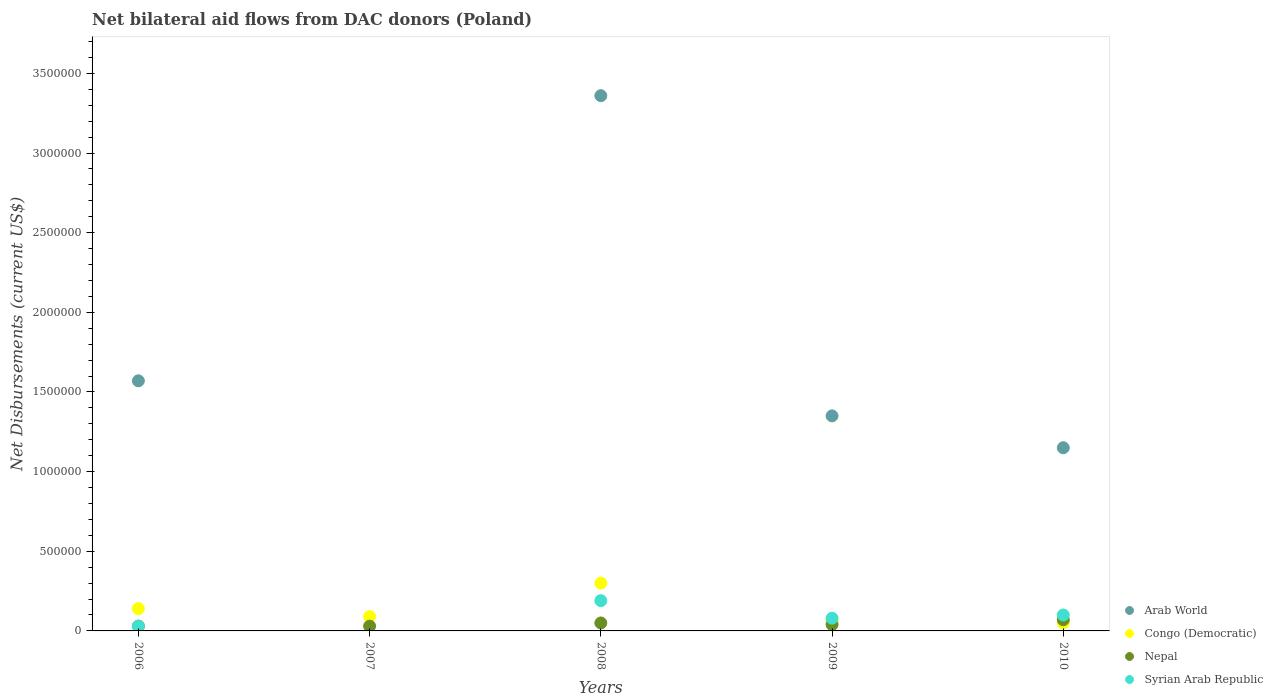Is the number of dotlines equal to the number of legend labels?
Ensure brevity in your answer.  No. What is the net bilateral aid flows in Nepal in 2007?
Make the answer very short. 3.00e+04. Across all years, what is the maximum net bilateral aid flows in Arab World?
Your answer should be very brief. 3.36e+06. What is the total net bilateral aid flows in Arab World in the graph?
Your response must be concise. 7.43e+06. What is the difference between the net bilateral aid flows in Nepal in 2006 and that in 2010?
Your answer should be compact. -4.00e+04. What is the difference between the net bilateral aid flows in Nepal in 2007 and the net bilateral aid flows in Arab World in 2010?
Ensure brevity in your answer.  -1.12e+06. What is the average net bilateral aid flows in Nepal per year?
Provide a succinct answer. 4.40e+04. In the year 2008, what is the difference between the net bilateral aid flows in Nepal and net bilateral aid flows in Arab World?
Your response must be concise. -3.31e+06. What is the ratio of the net bilateral aid flows in Congo (Democratic) in 2007 to that in 2009?
Keep it short and to the point. 1.5. What is the difference between the highest and the second highest net bilateral aid flows in Arab World?
Provide a short and direct response. 1.79e+06. What is the difference between the highest and the lowest net bilateral aid flows in Congo (Democratic)?
Your answer should be very brief. 2.50e+05. In how many years, is the net bilateral aid flows in Syrian Arab Republic greater than the average net bilateral aid flows in Syrian Arab Republic taken over all years?
Give a very brief answer. 2. Is the sum of the net bilateral aid flows in Syrian Arab Republic in 2008 and 2010 greater than the maximum net bilateral aid flows in Nepal across all years?
Ensure brevity in your answer.  Yes. Is it the case that in every year, the sum of the net bilateral aid flows in Arab World and net bilateral aid flows in Syrian Arab Republic  is greater than the sum of net bilateral aid flows in Nepal and net bilateral aid flows in Congo (Democratic)?
Ensure brevity in your answer.  No. Is it the case that in every year, the sum of the net bilateral aid flows in Syrian Arab Republic and net bilateral aid flows in Nepal  is greater than the net bilateral aid flows in Arab World?
Your answer should be very brief. No. Is the net bilateral aid flows in Syrian Arab Republic strictly greater than the net bilateral aid flows in Nepal over the years?
Give a very brief answer. No. Is the net bilateral aid flows in Nepal strictly less than the net bilateral aid flows in Arab World over the years?
Make the answer very short. No. How many dotlines are there?
Your response must be concise. 4. Are the values on the major ticks of Y-axis written in scientific E-notation?
Provide a succinct answer. No. Where does the legend appear in the graph?
Provide a short and direct response. Bottom right. How are the legend labels stacked?
Your answer should be compact. Vertical. What is the title of the graph?
Offer a very short reply. Net bilateral aid flows from DAC donors (Poland). What is the label or title of the Y-axis?
Keep it short and to the point. Net Disbursements (current US$). What is the Net Disbursements (current US$) in Arab World in 2006?
Your response must be concise. 1.57e+06. What is the Net Disbursements (current US$) in Congo (Democratic) in 2006?
Your answer should be very brief. 1.40e+05. What is the Net Disbursements (current US$) in Nepal in 2006?
Keep it short and to the point. 3.00e+04. What is the Net Disbursements (current US$) of Congo (Democratic) in 2007?
Make the answer very short. 9.00e+04. What is the Net Disbursements (current US$) in Nepal in 2007?
Your response must be concise. 3.00e+04. What is the Net Disbursements (current US$) of Syrian Arab Republic in 2007?
Provide a short and direct response. 0. What is the Net Disbursements (current US$) of Arab World in 2008?
Give a very brief answer. 3.36e+06. What is the Net Disbursements (current US$) of Syrian Arab Republic in 2008?
Your response must be concise. 1.90e+05. What is the Net Disbursements (current US$) of Arab World in 2009?
Ensure brevity in your answer.  1.35e+06. What is the Net Disbursements (current US$) in Congo (Democratic) in 2009?
Offer a very short reply. 6.00e+04. What is the Net Disbursements (current US$) in Syrian Arab Republic in 2009?
Provide a succinct answer. 8.00e+04. What is the Net Disbursements (current US$) of Arab World in 2010?
Ensure brevity in your answer.  1.15e+06. What is the Net Disbursements (current US$) in Congo (Democratic) in 2010?
Keep it short and to the point. 5.00e+04. What is the Net Disbursements (current US$) of Syrian Arab Republic in 2010?
Keep it short and to the point. 1.00e+05. Across all years, what is the maximum Net Disbursements (current US$) in Arab World?
Your answer should be very brief. 3.36e+06. Across all years, what is the maximum Net Disbursements (current US$) in Congo (Democratic)?
Provide a succinct answer. 3.00e+05. Across all years, what is the maximum Net Disbursements (current US$) in Syrian Arab Republic?
Your response must be concise. 1.90e+05. Across all years, what is the minimum Net Disbursements (current US$) in Nepal?
Keep it short and to the point. 3.00e+04. What is the total Net Disbursements (current US$) in Arab World in the graph?
Provide a short and direct response. 7.43e+06. What is the total Net Disbursements (current US$) in Congo (Democratic) in the graph?
Provide a short and direct response. 6.40e+05. What is the total Net Disbursements (current US$) in Nepal in the graph?
Your answer should be very brief. 2.20e+05. What is the total Net Disbursements (current US$) of Syrian Arab Republic in the graph?
Keep it short and to the point. 4.00e+05. What is the difference between the Net Disbursements (current US$) in Nepal in 2006 and that in 2007?
Your answer should be very brief. 0. What is the difference between the Net Disbursements (current US$) in Arab World in 2006 and that in 2008?
Offer a terse response. -1.79e+06. What is the difference between the Net Disbursements (current US$) in Congo (Democratic) in 2006 and that in 2008?
Offer a very short reply. -1.60e+05. What is the difference between the Net Disbursements (current US$) in Nepal in 2006 and that in 2008?
Provide a short and direct response. -2.00e+04. What is the difference between the Net Disbursements (current US$) in Arab World in 2006 and that in 2009?
Your response must be concise. 2.20e+05. What is the difference between the Net Disbursements (current US$) of Congo (Democratic) in 2006 and that in 2009?
Your answer should be very brief. 8.00e+04. What is the difference between the Net Disbursements (current US$) of Nepal in 2006 and that in 2009?
Ensure brevity in your answer.  -10000. What is the difference between the Net Disbursements (current US$) in Syrian Arab Republic in 2006 and that in 2009?
Your response must be concise. -5.00e+04. What is the difference between the Net Disbursements (current US$) in Syrian Arab Republic in 2006 and that in 2010?
Provide a succinct answer. -7.00e+04. What is the difference between the Net Disbursements (current US$) in Congo (Democratic) in 2007 and that in 2008?
Your response must be concise. -2.10e+05. What is the difference between the Net Disbursements (current US$) of Nepal in 2007 and that in 2008?
Your answer should be compact. -2.00e+04. What is the difference between the Net Disbursements (current US$) in Congo (Democratic) in 2007 and that in 2009?
Your response must be concise. 3.00e+04. What is the difference between the Net Disbursements (current US$) in Congo (Democratic) in 2007 and that in 2010?
Offer a very short reply. 4.00e+04. What is the difference between the Net Disbursements (current US$) of Arab World in 2008 and that in 2009?
Your answer should be very brief. 2.01e+06. What is the difference between the Net Disbursements (current US$) in Nepal in 2008 and that in 2009?
Offer a very short reply. 10000. What is the difference between the Net Disbursements (current US$) of Arab World in 2008 and that in 2010?
Provide a short and direct response. 2.21e+06. What is the difference between the Net Disbursements (current US$) of Nepal in 2008 and that in 2010?
Offer a terse response. -2.00e+04. What is the difference between the Net Disbursements (current US$) in Syrian Arab Republic in 2009 and that in 2010?
Offer a terse response. -2.00e+04. What is the difference between the Net Disbursements (current US$) of Arab World in 2006 and the Net Disbursements (current US$) of Congo (Democratic) in 2007?
Your response must be concise. 1.48e+06. What is the difference between the Net Disbursements (current US$) of Arab World in 2006 and the Net Disbursements (current US$) of Nepal in 2007?
Provide a short and direct response. 1.54e+06. What is the difference between the Net Disbursements (current US$) of Congo (Democratic) in 2006 and the Net Disbursements (current US$) of Nepal in 2007?
Keep it short and to the point. 1.10e+05. What is the difference between the Net Disbursements (current US$) of Arab World in 2006 and the Net Disbursements (current US$) of Congo (Democratic) in 2008?
Keep it short and to the point. 1.27e+06. What is the difference between the Net Disbursements (current US$) of Arab World in 2006 and the Net Disbursements (current US$) of Nepal in 2008?
Your answer should be compact. 1.52e+06. What is the difference between the Net Disbursements (current US$) in Arab World in 2006 and the Net Disbursements (current US$) in Syrian Arab Republic in 2008?
Make the answer very short. 1.38e+06. What is the difference between the Net Disbursements (current US$) in Nepal in 2006 and the Net Disbursements (current US$) in Syrian Arab Republic in 2008?
Offer a terse response. -1.60e+05. What is the difference between the Net Disbursements (current US$) in Arab World in 2006 and the Net Disbursements (current US$) in Congo (Democratic) in 2009?
Your response must be concise. 1.51e+06. What is the difference between the Net Disbursements (current US$) of Arab World in 2006 and the Net Disbursements (current US$) of Nepal in 2009?
Offer a terse response. 1.53e+06. What is the difference between the Net Disbursements (current US$) in Arab World in 2006 and the Net Disbursements (current US$) in Syrian Arab Republic in 2009?
Your answer should be compact. 1.49e+06. What is the difference between the Net Disbursements (current US$) in Congo (Democratic) in 2006 and the Net Disbursements (current US$) in Nepal in 2009?
Offer a very short reply. 1.00e+05. What is the difference between the Net Disbursements (current US$) in Congo (Democratic) in 2006 and the Net Disbursements (current US$) in Syrian Arab Republic in 2009?
Make the answer very short. 6.00e+04. What is the difference between the Net Disbursements (current US$) of Nepal in 2006 and the Net Disbursements (current US$) of Syrian Arab Republic in 2009?
Make the answer very short. -5.00e+04. What is the difference between the Net Disbursements (current US$) of Arab World in 2006 and the Net Disbursements (current US$) of Congo (Democratic) in 2010?
Offer a terse response. 1.52e+06. What is the difference between the Net Disbursements (current US$) in Arab World in 2006 and the Net Disbursements (current US$) in Nepal in 2010?
Your answer should be very brief. 1.50e+06. What is the difference between the Net Disbursements (current US$) of Arab World in 2006 and the Net Disbursements (current US$) of Syrian Arab Republic in 2010?
Offer a terse response. 1.47e+06. What is the difference between the Net Disbursements (current US$) in Congo (Democratic) in 2006 and the Net Disbursements (current US$) in Nepal in 2010?
Make the answer very short. 7.00e+04. What is the difference between the Net Disbursements (current US$) in Congo (Democratic) in 2006 and the Net Disbursements (current US$) in Syrian Arab Republic in 2010?
Ensure brevity in your answer.  4.00e+04. What is the difference between the Net Disbursements (current US$) of Nepal in 2006 and the Net Disbursements (current US$) of Syrian Arab Republic in 2010?
Ensure brevity in your answer.  -7.00e+04. What is the difference between the Net Disbursements (current US$) in Congo (Democratic) in 2007 and the Net Disbursements (current US$) in Syrian Arab Republic in 2008?
Make the answer very short. -1.00e+05. What is the difference between the Net Disbursements (current US$) of Nepal in 2007 and the Net Disbursements (current US$) of Syrian Arab Republic in 2008?
Provide a short and direct response. -1.60e+05. What is the difference between the Net Disbursements (current US$) in Congo (Democratic) in 2007 and the Net Disbursements (current US$) in Nepal in 2009?
Keep it short and to the point. 5.00e+04. What is the difference between the Net Disbursements (current US$) of Congo (Democratic) in 2007 and the Net Disbursements (current US$) of Syrian Arab Republic in 2010?
Your answer should be very brief. -10000. What is the difference between the Net Disbursements (current US$) in Nepal in 2007 and the Net Disbursements (current US$) in Syrian Arab Republic in 2010?
Give a very brief answer. -7.00e+04. What is the difference between the Net Disbursements (current US$) of Arab World in 2008 and the Net Disbursements (current US$) of Congo (Democratic) in 2009?
Your answer should be compact. 3.30e+06. What is the difference between the Net Disbursements (current US$) in Arab World in 2008 and the Net Disbursements (current US$) in Nepal in 2009?
Keep it short and to the point. 3.32e+06. What is the difference between the Net Disbursements (current US$) of Arab World in 2008 and the Net Disbursements (current US$) of Syrian Arab Republic in 2009?
Offer a very short reply. 3.28e+06. What is the difference between the Net Disbursements (current US$) of Congo (Democratic) in 2008 and the Net Disbursements (current US$) of Nepal in 2009?
Make the answer very short. 2.60e+05. What is the difference between the Net Disbursements (current US$) of Nepal in 2008 and the Net Disbursements (current US$) of Syrian Arab Republic in 2009?
Make the answer very short. -3.00e+04. What is the difference between the Net Disbursements (current US$) in Arab World in 2008 and the Net Disbursements (current US$) in Congo (Democratic) in 2010?
Offer a terse response. 3.31e+06. What is the difference between the Net Disbursements (current US$) of Arab World in 2008 and the Net Disbursements (current US$) of Nepal in 2010?
Make the answer very short. 3.29e+06. What is the difference between the Net Disbursements (current US$) in Arab World in 2008 and the Net Disbursements (current US$) in Syrian Arab Republic in 2010?
Provide a succinct answer. 3.26e+06. What is the difference between the Net Disbursements (current US$) in Congo (Democratic) in 2008 and the Net Disbursements (current US$) in Nepal in 2010?
Keep it short and to the point. 2.30e+05. What is the difference between the Net Disbursements (current US$) of Congo (Democratic) in 2008 and the Net Disbursements (current US$) of Syrian Arab Republic in 2010?
Your answer should be compact. 2.00e+05. What is the difference between the Net Disbursements (current US$) of Arab World in 2009 and the Net Disbursements (current US$) of Congo (Democratic) in 2010?
Offer a terse response. 1.30e+06. What is the difference between the Net Disbursements (current US$) in Arab World in 2009 and the Net Disbursements (current US$) in Nepal in 2010?
Give a very brief answer. 1.28e+06. What is the difference between the Net Disbursements (current US$) in Arab World in 2009 and the Net Disbursements (current US$) in Syrian Arab Republic in 2010?
Provide a short and direct response. 1.25e+06. What is the difference between the Net Disbursements (current US$) in Nepal in 2009 and the Net Disbursements (current US$) in Syrian Arab Republic in 2010?
Offer a terse response. -6.00e+04. What is the average Net Disbursements (current US$) of Arab World per year?
Your answer should be compact. 1.49e+06. What is the average Net Disbursements (current US$) of Congo (Democratic) per year?
Your answer should be compact. 1.28e+05. What is the average Net Disbursements (current US$) in Nepal per year?
Make the answer very short. 4.40e+04. In the year 2006, what is the difference between the Net Disbursements (current US$) in Arab World and Net Disbursements (current US$) in Congo (Democratic)?
Your response must be concise. 1.43e+06. In the year 2006, what is the difference between the Net Disbursements (current US$) of Arab World and Net Disbursements (current US$) of Nepal?
Ensure brevity in your answer.  1.54e+06. In the year 2006, what is the difference between the Net Disbursements (current US$) in Arab World and Net Disbursements (current US$) in Syrian Arab Republic?
Your answer should be compact. 1.54e+06. In the year 2006, what is the difference between the Net Disbursements (current US$) of Congo (Democratic) and Net Disbursements (current US$) of Nepal?
Make the answer very short. 1.10e+05. In the year 2006, what is the difference between the Net Disbursements (current US$) in Congo (Democratic) and Net Disbursements (current US$) in Syrian Arab Republic?
Provide a short and direct response. 1.10e+05. In the year 2006, what is the difference between the Net Disbursements (current US$) in Nepal and Net Disbursements (current US$) in Syrian Arab Republic?
Offer a very short reply. 0. In the year 2008, what is the difference between the Net Disbursements (current US$) of Arab World and Net Disbursements (current US$) of Congo (Democratic)?
Give a very brief answer. 3.06e+06. In the year 2008, what is the difference between the Net Disbursements (current US$) of Arab World and Net Disbursements (current US$) of Nepal?
Keep it short and to the point. 3.31e+06. In the year 2008, what is the difference between the Net Disbursements (current US$) in Arab World and Net Disbursements (current US$) in Syrian Arab Republic?
Keep it short and to the point. 3.17e+06. In the year 2008, what is the difference between the Net Disbursements (current US$) of Congo (Democratic) and Net Disbursements (current US$) of Nepal?
Give a very brief answer. 2.50e+05. In the year 2008, what is the difference between the Net Disbursements (current US$) in Nepal and Net Disbursements (current US$) in Syrian Arab Republic?
Provide a succinct answer. -1.40e+05. In the year 2009, what is the difference between the Net Disbursements (current US$) in Arab World and Net Disbursements (current US$) in Congo (Democratic)?
Provide a short and direct response. 1.29e+06. In the year 2009, what is the difference between the Net Disbursements (current US$) in Arab World and Net Disbursements (current US$) in Nepal?
Your answer should be very brief. 1.31e+06. In the year 2009, what is the difference between the Net Disbursements (current US$) in Arab World and Net Disbursements (current US$) in Syrian Arab Republic?
Keep it short and to the point. 1.27e+06. In the year 2009, what is the difference between the Net Disbursements (current US$) of Congo (Democratic) and Net Disbursements (current US$) of Nepal?
Offer a terse response. 2.00e+04. In the year 2009, what is the difference between the Net Disbursements (current US$) in Nepal and Net Disbursements (current US$) in Syrian Arab Republic?
Give a very brief answer. -4.00e+04. In the year 2010, what is the difference between the Net Disbursements (current US$) of Arab World and Net Disbursements (current US$) of Congo (Democratic)?
Your answer should be very brief. 1.10e+06. In the year 2010, what is the difference between the Net Disbursements (current US$) of Arab World and Net Disbursements (current US$) of Nepal?
Provide a succinct answer. 1.08e+06. In the year 2010, what is the difference between the Net Disbursements (current US$) in Arab World and Net Disbursements (current US$) in Syrian Arab Republic?
Provide a short and direct response. 1.05e+06. In the year 2010, what is the difference between the Net Disbursements (current US$) in Congo (Democratic) and Net Disbursements (current US$) in Nepal?
Offer a very short reply. -2.00e+04. In the year 2010, what is the difference between the Net Disbursements (current US$) of Congo (Democratic) and Net Disbursements (current US$) of Syrian Arab Republic?
Keep it short and to the point. -5.00e+04. In the year 2010, what is the difference between the Net Disbursements (current US$) of Nepal and Net Disbursements (current US$) of Syrian Arab Republic?
Your answer should be compact. -3.00e+04. What is the ratio of the Net Disbursements (current US$) in Congo (Democratic) in 2006 to that in 2007?
Offer a terse response. 1.56. What is the ratio of the Net Disbursements (current US$) in Nepal in 2006 to that in 2007?
Keep it short and to the point. 1. What is the ratio of the Net Disbursements (current US$) of Arab World in 2006 to that in 2008?
Provide a succinct answer. 0.47. What is the ratio of the Net Disbursements (current US$) in Congo (Democratic) in 2006 to that in 2008?
Provide a succinct answer. 0.47. What is the ratio of the Net Disbursements (current US$) in Syrian Arab Republic in 2006 to that in 2008?
Your answer should be very brief. 0.16. What is the ratio of the Net Disbursements (current US$) in Arab World in 2006 to that in 2009?
Provide a short and direct response. 1.16. What is the ratio of the Net Disbursements (current US$) of Congo (Democratic) in 2006 to that in 2009?
Provide a short and direct response. 2.33. What is the ratio of the Net Disbursements (current US$) of Arab World in 2006 to that in 2010?
Give a very brief answer. 1.37. What is the ratio of the Net Disbursements (current US$) of Nepal in 2006 to that in 2010?
Keep it short and to the point. 0.43. What is the ratio of the Net Disbursements (current US$) of Syrian Arab Republic in 2006 to that in 2010?
Make the answer very short. 0.3. What is the ratio of the Net Disbursements (current US$) in Nepal in 2007 to that in 2008?
Keep it short and to the point. 0.6. What is the ratio of the Net Disbursements (current US$) in Nepal in 2007 to that in 2010?
Keep it short and to the point. 0.43. What is the ratio of the Net Disbursements (current US$) in Arab World in 2008 to that in 2009?
Ensure brevity in your answer.  2.49. What is the ratio of the Net Disbursements (current US$) in Nepal in 2008 to that in 2009?
Provide a succinct answer. 1.25. What is the ratio of the Net Disbursements (current US$) of Syrian Arab Republic in 2008 to that in 2009?
Offer a very short reply. 2.38. What is the ratio of the Net Disbursements (current US$) in Arab World in 2008 to that in 2010?
Provide a succinct answer. 2.92. What is the ratio of the Net Disbursements (current US$) of Arab World in 2009 to that in 2010?
Your response must be concise. 1.17. What is the ratio of the Net Disbursements (current US$) of Congo (Democratic) in 2009 to that in 2010?
Make the answer very short. 1.2. What is the ratio of the Net Disbursements (current US$) of Syrian Arab Republic in 2009 to that in 2010?
Offer a terse response. 0.8. What is the difference between the highest and the second highest Net Disbursements (current US$) in Arab World?
Give a very brief answer. 1.79e+06. What is the difference between the highest and the second highest Net Disbursements (current US$) of Congo (Democratic)?
Give a very brief answer. 1.60e+05. What is the difference between the highest and the second highest Net Disbursements (current US$) of Nepal?
Your answer should be very brief. 2.00e+04. What is the difference between the highest and the second highest Net Disbursements (current US$) of Syrian Arab Republic?
Your answer should be very brief. 9.00e+04. What is the difference between the highest and the lowest Net Disbursements (current US$) in Arab World?
Offer a very short reply. 3.36e+06. What is the difference between the highest and the lowest Net Disbursements (current US$) in Congo (Democratic)?
Offer a terse response. 2.50e+05. What is the difference between the highest and the lowest Net Disbursements (current US$) of Nepal?
Make the answer very short. 4.00e+04. What is the difference between the highest and the lowest Net Disbursements (current US$) in Syrian Arab Republic?
Ensure brevity in your answer.  1.90e+05. 